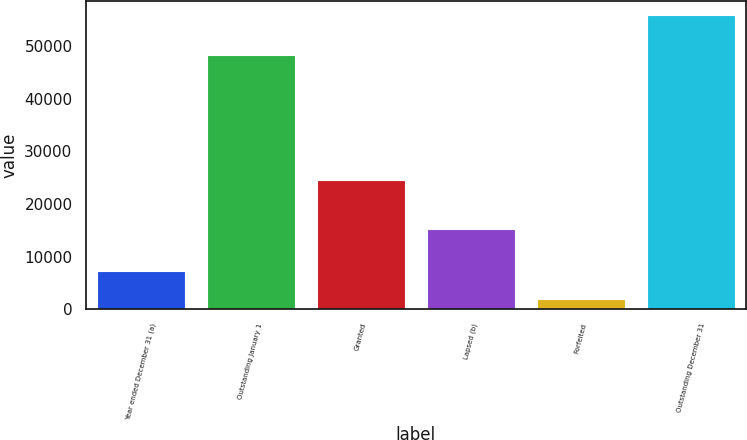<chart> <loc_0><loc_0><loc_500><loc_500><bar_chart><fcel>Year ended December 31 (a)<fcel>Outstanding January 1<fcel>Granted<fcel>Lapsed (b)<fcel>Forfeited<fcel>Outstanding December 31<nl><fcel>7272.5<fcel>48336<fcel>24624<fcel>15203<fcel>1871<fcel>55886<nl></chart> 